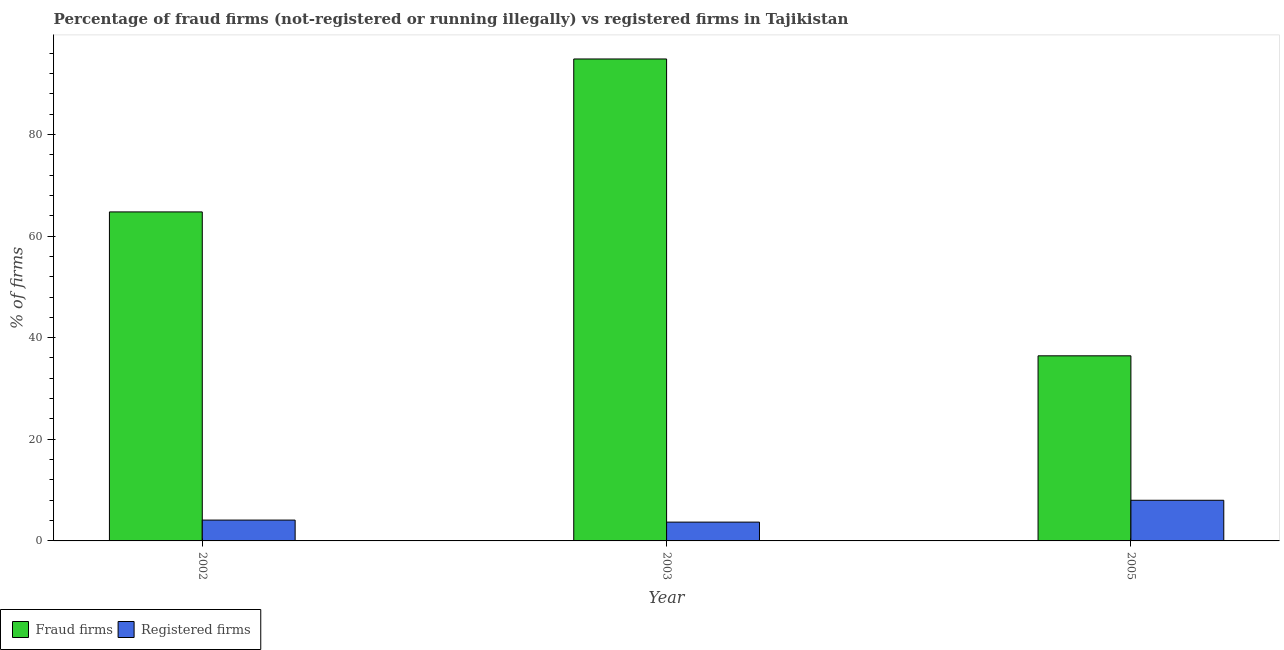How many different coloured bars are there?
Offer a very short reply. 2. How many groups of bars are there?
Your answer should be very brief. 3. Are the number of bars on each tick of the X-axis equal?
Ensure brevity in your answer.  Yes. What is the label of the 2nd group of bars from the left?
Offer a terse response. 2003. What is the percentage of registered firms in 2003?
Make the answer very short. 3.7. In which year was the percentage of fraud firms minimum?
Your answer should be very brief. 2005. What is the total percentage of registered firms in the graph?
Your answer should be compact. 15.8. What is the difference between the percentage of fraud firms in 2003 and that in 2005?
Your response must be concise. 58.42. What is the difference between the percentage of registered firms in 2005 and the percentage of fraud firms in 2002?
Keep it short and to the point. 3.9. What is the average percentage of fraud firms per year?
Provide a succinct answer. 65.34. In the year 2005, what is the difference between the percentage of registered firms and percentage of fraud firms?
Offer a very short reply. 0. In how many years, is the percentage of fraud firms greater than 16 %?
Provide a succinct answer. 3. What is the ratio of the percentage of fraud firms in 2002 to that in 2005?
Offer a terse response. 1.78. Is the difference between the percentage of registered firms in 2002 and 2003 greater than the difference between the percentage of fraud firms in 2002 and 2003?
Provide a short and direct response. No. What is the difference between the highest and the second highest percentage of fraud firms?
Ensure brevity in your answer.  30.1. What is the difference between the highest and the lowest percentage of registered firms?
Keep it short and to the point. 4.3. Is the sum of the percentage of registered firms in 2002 and 2003 greater than the maximum percentage of fraud firms across all years?
Provide a short and direct response. No. What does the 1st bar from the left in 2005 represents?
Offer a very short reply. Fraud firms. What does the 1st bar from the right in 2002 represents?
Provide a succinct answer. Registered firms. Does the graph contain any zero values?
Your answer should be compact. No. How many legend labels are there?
Provide a short and direct response. 2. What is the title of the graph?
Keep it short and to the point. Percentage of fraud firms (not-registered or running illegally) vs registered firms in Tajikistan. What is the label or title of the Y-axis?
Provide a short and direct response. % of firms. What is the % of firms in Fraud firms in 2002?
Provide a succinct answer. 64.75. What is the % of firms in Registered firms in 2002?
Offer a terse response. 4.1. What is the % of firms in Fraud firms in 2003?
Give a very brief answer. 94.85. What is the % of firms of Registered firms in 2003?
Offer a very short reply. 3.7. What is the % of firms in Fraud firms in 2005?
Your answer should be compact. 36.43. Across all years, what is the maximum % of firms of Fraud firms?
Offer a terse response. 94.85. Across all years, what is the maximum % of firms of Registered firms?
Provide a short and direct response. 8. Across all years, what is the minimum % of firms of Fraud firms?
Offer a very short reply. 36.43. What is the total % of firms in Fraud firms in the graph?
Give a very brief answer. 196.03. What is the difference between the % of firms of Fraud firms in 2002 and that in 2003?
Your answer should be compact. -30.1. What is the difference between the % of firms in Registered firms in 2002 and that in 2003?
Your answer should be very brief. 0.4. What is the difference between the % of firms of Fraud firms in 2002 and that in 2005?
Provide a short and direct response. 28.32. What is the difference between the % of firms in Fraud firms in 2003 and that in 2005?
Provide a short and direct response. 58.42. What is the difference between the % of firms of Fraud firms in 2002 and the % of firms of Registered firms in 2003?
Keep it short and to the point. 61.05. What is the difference between the % of firms of Fraud firms in 2002 and the % of firms of Registered firms in 2005?
Provide a succinct answer. 56.75. What is the difference between the % of firms in Fraud firms in 2003 and the % of firms in Registered firms in 2005?
Make the answer very short. 86.85. What is the average % of firms in Fraud firms per year?
Offer a terse response. 65.34. What is the average % of firms of Registered firms per year?
Keep it short and to the point. 5.27. In the year 2002, what is the difference between the % of firms in Fraud firms and % of firms in Registered firms?
Ensure brevity in your answer.  60.65. In the year 2003, what is the difference between the % of firms in Fraud firms and % of firms in Registered firms?
Your response must be concise. 91.15. In the year 2005, what is the difference between the % of firms in Fraud firms and % of firms in Registered firms?
Ensure brevity in your answer.  28.43. What is the ratio of the % of firms of Fraud firms in 2002 to that in 2003?
Your response must be concise. 0.68. What is the ratio of the % of firms of Registered firms in 2002 to that in 2003?
Your answer should be very brief. 1.11. What is the ratio of the % of firms in Fraud firms in 2002 to that in 2005?
Provide a succinct answer. 1.78. What is the ratio of the % of firms in Registered firms in 2002 to that in 2005?
Your answer should be compact. 0.51. What is the ratio of the % of firms in Fraud firms in 2003 to that in 2005?
Offer a terse response. 2.6. What is the ratio of the % of firms of Registered firms in 2003 to that in 2005?
Ensure brevity in your answer.  0.46. What is the difference between the highest and the second highest % of firms of Fraud firms?
Ensure brevity in your answer.  30.1. What is the difference between the highest and the second highest % of firms of Registered firms?
Offer a very short reply. 3.9. What is the difference between the highest and the lowest % of firms in Fraud firms?
Ensure brevity in your answer.  58.42. 